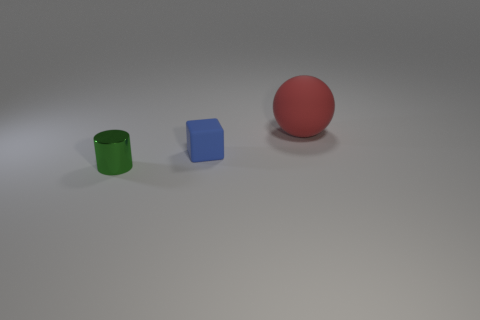Add 1 matte balls. How many objects exist? 4 Subtract all spheres. How many objects are left? 2 Subtract all red matte things. Subtract all tiny brown things. How many objects are left? 2 Add 3 green metal cylinders. How many green metal cylinders are left? 4 Add 1 tiny things. How many tiny things exist? 3 Subtract 0 purple blocks. How many objects are left? 3 